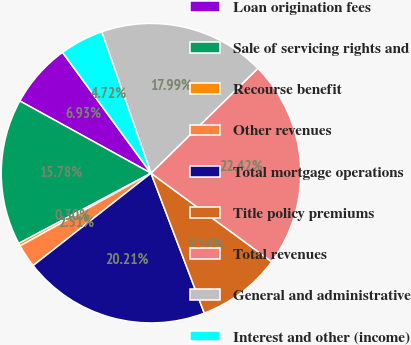Convert chart to OTSL. <chart><loc_0><loc_0><loc_500><loc_500><pie_chart><fcel>Loan origination fees<fcel>Sale of servicing rights and<fcel>Recourse benefit<fcel>Other revenues<fcel>Total mortgage operations<fcel>Title policy premiums<fcel>Total revenues<fcel>General and administrative<fcel>Interest and other (income)<nl><fcel>6.93%<fcel>15.78%<fcel>0.3%<fcel>2.51%<fcel>20.21%<fcel>9.14%<fcel>22.42%<fcel>17.99%<fcel>4.72%<nl></chart> 